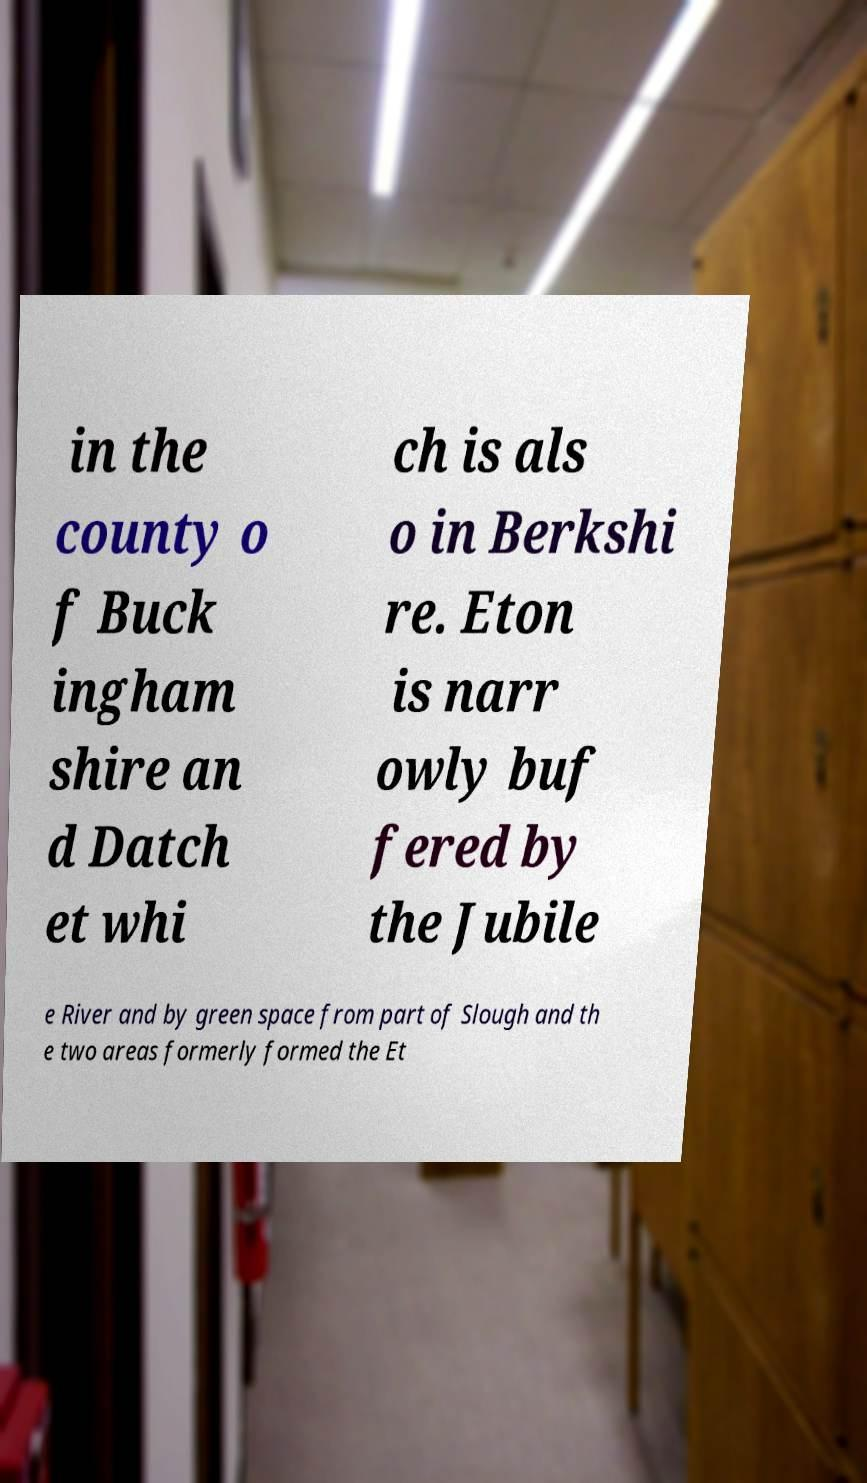There's text embedded in this image that I need extracted. Can you transcribe it verbatim? in the county o f Buck ingham shire an d Datch et whi ch is als o in Berkshi re. Eton is narr owly buf fered by the Jubile e River and by green space from part of Slough and th e two areas formerly formed the Et 